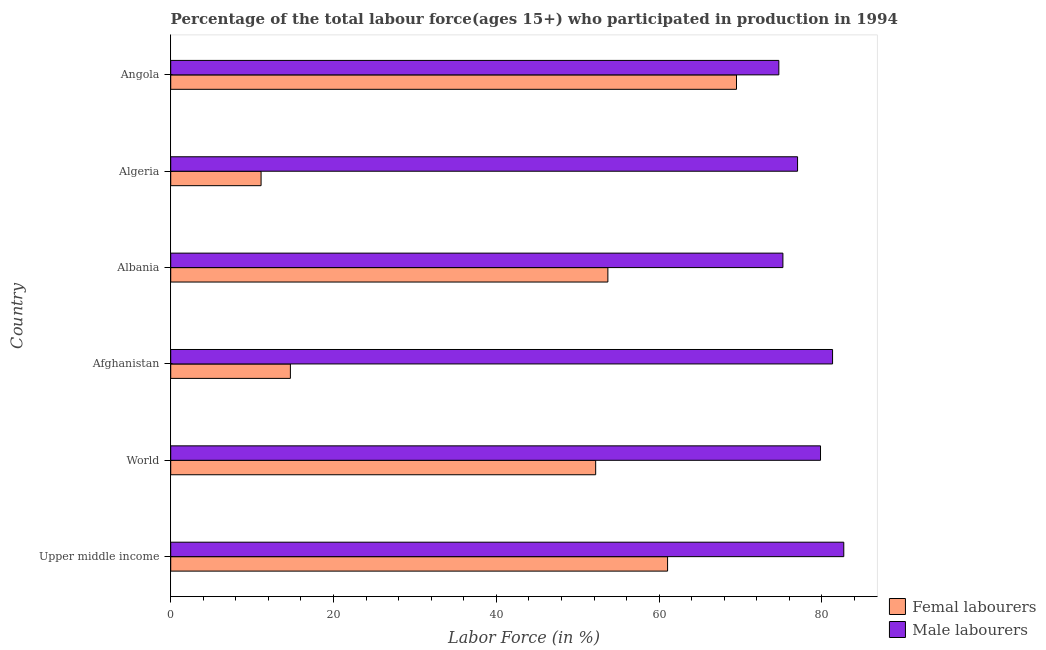How many different coloured bars are there?
Keep it short and to the point. 2. How many groups of bars are there?
Offer a very short reply. 6. How many bars are there on the 3rd tick from the top?
Offer a terse response. 2. What is the label of the 1st group of bars from the top?
Your answer should be very brief. Angola. What is the percentage of male labour force in Algeria?
Provide a short and direct response. 77. Across all countries, what is the maximum percentage of male labour force?
Provide a succinct answer. 82.68. Across all countries, what is the minimum percentage of female labor force?
Offer a terse response. 11.1. In which country was the percentage of female labor force maximum?
Your answer should be very brief. Angola. In which country was the percentage of male labour force minimum?
Offer a terse response. Angola. What is the total percentage of female labor force in the graph?
Provide a succinct answer. 262.23. What is the difference between the percentage of male labour force in Angola and the percentage of female labor force in Albania?
Your answer should be compact. 21. What is the average percentage of female labor force per country?
Your answer should be compact. 43.71. What is the difference between the percentage of female labor force and percentage of male labour force in Algeria?
Provide a succinct answer. -65.9. In how many countries, is the percentage of female labor force greater than 24 %?
Your answer should be compact. 4. What is the ratio of the percentage of male labour force in Angola to that in Upper middle income?
Make the answer very short. 0.9. Is the difference between the percentage of male labour force in Angola and World greater than the difference between the percentage of female labor force in Angola and World?
Ensure brevity in your answer.  No. What is the difference between the highest and the second highest percentage of male labour force?
Your response must be concise. 1.38. What is the difference between the highest and the lowest percentage of female labor force?
Your response must be concise. 58.4. Is the sum of the percentage of male labour force in Algeria and Angola greater than the maximum percentage of female labor force across all countries?
Your answer should be very brief. Yes. What does the 1st bar from the top in Angola represents?
Make the answer very short. Male labourers. What does the 1st bar from the bottom in Algeria represents?
Offer a terse response. Femal labourers. Does the graph contain grids?
Ensure brevity in your answer.  No. What is the title of the graph?
Give a very brief answer. Percentage of the total labour force(ages 15+) who participated in production in 1994. What is the label or title of the X-axis?
Keep it short and to the point. Labor Force (in %). What is the Labor Force (in %) of Femal labourers in Upper middle income?
Provide a succinct answer. 61.03. What is the Labor Force (in %) in Male labourers in Upper middle income?
Ensure brevity in your answer.  82.68. What is the Labor Force (in %) of Femal labourers in World?
Ensure brevity in your answer.  52.2. What is the Labor Force (in %) of Male labourers in World?
Provide a short and direct response. 79.82. What is the Labor Force (in %) in Femal labourers in Afghanistan?
Your answer should be compact. 14.7. What is the Labor Force (in %) in Male labourers in Afghanistan?
Your response must be concise. 81.3. What is the Labor Force (in %) in Femal labourers in Albania?
Offer a terse response. 53.7. What is the Labor Force (in %) in Male labourers in Albania?
Provide a short and direct response. 75.2. What is the Labor Force (in %) of Femal labourers in Algeria?
Your answer should be compact. 11.1. What is the Labor Force (in %) in Femal labourers in Angola?
Offer a very short reply. 69.5. What is the Labor Force (in %) in Male labourers in Angola?
Offer a very short reply. 74.7. Across all countries, what is the maximum Labor Force (in %) in Femal labourers?
Ensure brevity in your answer.  69.5. Across all countries, what is the maximum Labor Force (in %) in Male labourers?
Make the answer very short. 82.68. Across all countries, what is the minimum Labor Force (in %) in Femal labourers?
Ensure brevity in your answer.  11.1. Across all countries, what is the minimum Labor Force (in %) in Male labourers?
Offer a very short reply. 74.7. What is the total Labor Force (in %) in Femal labourers in the graph?
Provide a succinct answer. 262.23. What is the total Labor Force (in %) of Male labourers in the graph?
Give a very brief answer. 470.7. What is the difference between the Labor Force (in %) in Femal labourers in Upper middle income and that in World?
Your response must be concise. 8.83. What is the difference between the Labor Force (in %) of Male labourers in Upper middle income and that in World?
Make the answer very short. 2.86. What is the difference between the Labor Force (in %) of Femal labourers in Upper middle income and that in Afghanistan?
Provide a succinct answer. 46.33. What is the difference between the Labor Force (in %) in Male labourers in Upper middle income and that in Afghanistan?
Provide a succinct answer. 1.38. What is the difference between the Labor Force (in %) of Femal labourers in Upper middle income and that in Albania?
Your response must be concise. 7.33. What is the difference between the Labor Force (in %) of Male labourers in Upper middle income and that in Albania?
Ensure brevity in your answer.  7.48. What is the difference between the Labor Force (in %) of Femal labourers in Upper middle income and that in Algeria?
Ensure brevity in your answer.  49.93. What is the difference between the Labor Force (in %) in Male labourers in Upper middle income and that in Algeria?
Provide a short and direct response. 5.68. What is the difference between the Labor Force (in %) of Femal labourers in Upper middle income and that in Angola?
Offer a terse response. -8.47. What is the difference between the Labor Force (in %) in Male labourers in Upper middle income and that in Angola?
Ensure brevity in your answer.  7.98. What is the difference between the Labor Force (in %) of Femal labourers in World and that in Afghanistan?
Give a very brief answer. 37.5. What is the difference between the Labor Force (in %) of Male labourers in World and that in Afghanistan?
Your response must be concise. -1.48. What is the difference between the Labor Force (in %) in Femal labourers in World and that in Albania?
Provide a succinct answer. -1.5. What is the difference between the Labor Force (in %) of Male labourers in World and that in Albania?
Provide a succinct answer. 4.62. What is the difference between the Labor Force (in %) of Femal labourers in World and that in Algeria?
Your answer should be compact. 41.1. What is the difference between the Labor Force (in %) in Male labourers in World and that in Algeria?
Keep it short and to the point. 2.82. What is the difference between the Labor Force (in %) in Femal labourers in World and that in Angola?
Provide a succinct answer. -17.3. What is the difference between the Labor Force (in %) in Male labourers in World and that in Angola?
Your answer should be compact. 5.12. What is the difference between the Labor Force (in %) of Femal labourers in Afghanistan and that in Albania?
Provide a short and direct response. -39. What is the difference between the Labor Force (in %) of Male labourers in Afghanistan and that in Albania?
Ensure brevity in your answer.  6.1. What is the difference between the Labor Force (in %) in Femal labourers in Afghanistan and that in Algeria?
Your answer should be very brief. 3.6. What is the difference between the Labor Force (in %) of Femal labourers in Afghanistan and that in Angola?
Your answer should be very brief. -54.8. What is the difference between the Labor Force (in %) in Femal labourers in Albania and that in Algeria?
Your answer should be compact. 42.6. What is the difference between the Labor Force (in %) in Male labourers in Albania and that in Algeria?
Provide a succinct answer. -1.8. What is the difference between the Labor Force (in %) in Femal labourers in Albania and that in Angola?
Offer a very short reply. -15.8. What is the difference between the Labor Force (in %) in Male labourers in Albania and that in Angola?
Your answer should be compact. 0.5. What is the difference between the Labor Force (in %) of Femal labourers in Algeria and that in Angola?
Your answer should be very brief. -58.4. What is the difference between the Labor Force (in %) of Femal labourers in Upper middle income and the Labor Force (in %) of Male labourers in World?
Give a very brief answer. -18.79. What is the difference between the Labor Force (in %) in Femal labourers in Upper middle income and the Labor Force (in %) in Male labourers in Afghanistan?
Your answer should be compact. -20.27. What is the difference between the Labor Force (in %) of Femal labourers in Upper middle income and the Labor Force (in %) of Male labourers in Albania?
Make the answer very short. -14.17. What is the difference between the Labor Force (in %) in Femal labourers in Upper middle income and the Labor Force (in %) in Male labourers in Algeria?
Give a very brief answer. -15.97. What is the difference between the Labor Force (in %) of Femal labourers in Upper middle income and the Labor Force (in %) of Male labourers in Angola?
Keep it short and to the point. -13.67. What is the difference between the Labor Force (in %) of Femal labourers in World and the Labor Force (in %) of Male labourers in Afghanistan?
Your answer should be very brief. -29.1. What is the difference between the Labor Force (in %) of Femal labourers in World and the Labor Force (in %) of Male labourers in Albania?
Offer a very short reply. -23. What is the difference between the Labor Force (in %) of Femal labourers in World and the Labor Force (in %) of Male labourers in Algeria?
Your answer should be very brief. -24.8. What is the difference between the Labor Force (in %) of Femal labourers in World and the Labor Force (in %) of Male labourers in Angola?
Keep it short and to the point. -22.5. What is the difference between the Labor Force (in %) of Femal labourers in Afghanistan and the Labor Force (in %) of Male labourers in Albania?
Provide a succinct answer. -60.5. What is the difference between the Labor Force (in %) in Femal labourers in Afghanistan and the Labor Force (in %) in Male labourers in Algeria?
Provide a succinct answer. -62.3. What is the difference between the Labor Force (in %) in Femal labourers in Afghanistan and the Labor Force (in %) in Male labourers in Angola?
Your answer should be very brief. -60. What is the difference between the Labor Force (in %) of Femal labourers in Albania and the Labor Force (in %) of Male labourers in Algeria?
Provide a succinct answer. -23.3. What is the difference between the Labor Force (in %) of Femal labourers in Algeria and the Labor Force (in %) of Male labourers in Angola?
Provide a short and direct response. -63.6. What is the average Labor Force (in %) of Femal labourers per country?
Your response must be concise. 43.71. What is the average Labor Force (in %) of Male labourers per country?
Your response must be concise. 78.45. What is the difference between the Labor Force (in %) of Femal labourers and Labor Force (in %) of Male labourers in Upper middle income?
Provide a succinct answer. -21.64. What is the difference between the Labor Force (in %) in Femal labourers and Labor Force (in %) in Male labourers in World?
Offer a terse response. -27.62. What is the difference between the Labor Force (in %) of Femal labourers and Labor Force (in %) of Male labourers in Afghanistan?
Offer a terse response. -66.6. What is the difference between the Labor Force (in %) in Femal labourers and Labor Force (in %) in Male labourers in Albania?
Your response must be concise. -21.5. What is the difference between the Labor Force (in %) of Femal labourers and Labor Force (in %) of Male labourers in Algeria?
Your answer should be compact. -65.9. What is the difference between the Labor Force (in %) in Femal labourers and Labor Force (in %) in Male labourers in Angola?
Your response must be concise. -5.2. What is the ratio of the Labor Force (in %) of Femal labourers in Upper middle income to that in World?
Offer a terse response. 1.17. What is the ratio of the Labor Force (in %) in Male labourers in Upper middle income to that in World?
Give a very brief answer. 1.04. What is the ratio of the Labor Force (in %) in Femal labourers in Upper middle income to that in Afghanistan?
Keep it short and to the point. 4.15. What is the ratio of the Labor Force (in %) of Male labourers in Upper middle income to that in Afghanistan?
Offer a terse response. 1.02. What is the ratio of the Labor Force (in %) in Femal labourers in Upper middle income to that in Albania?
Your answer should be compact. 1.14. What is the ratio of the Labor Force (in %) of Male labourers in Upper middle income to that in Albania?
Ensure brevity in your answer.  1.1. What is the ratio of the Labor Force (in %) in Femal labourers in Upper middle income to that in Algeria?
Keep it short and to the point. 5.5. What is the ratio of the Labor Force (in %) of Male labourers in Upper middle income to that in Algeria?
Your response must be concise. 1.07. What is the ratio of the Labor Force (in %) in Femal labourers in Upper middle income to that in Angola?
Ensure brevity in your answer.  0.88. What is the ratio of the Labor Force (in %) of Male labourers in Upper middle income to that in Angola?
Offer a very short reply. 1.11. What is the ratio of the Labor Force (in %) in Femal labourers in World to that in Afghanistan?
Provide a succinct answer. 3.55. What is the ratio of the Labor Force (in %) of Male labourers in World to that in Afghanistan?
Your response must be concise. 0.98. What is the ratio of the Labor Force (in %) in Femal labourers in World to that in Albania?
Ensure brevity in your answer.  0.97. What is the ratio of the Labor Force (in %) of Male labourers in World to that in Albania?
Make the answer very short. 1.06. What is the ratio of the Labor Force (in %) in Femal labourers in World to that in Algeria?
Make the answer very short. 4.7. What is the ratio of the Labor Force (in %) of Male labourers in World to that in Algeria?
Keep it short and to the point. 1.04. What is the ratio of the Labor Force (in %) of Femal labourers in World to that in Angola?
Provide a short and direct response. 0.75. What is the ratio of the Labor Force (in %) in Male labourers in World to that in Angola?
Offer a terse response. 1.07. What is the ratio of the Labor Force (in %) of Femal labourers in Afghanistan to that in Albania?
Give a very brief answer. 0.27. What is the ratio of the Labor Force (in %) of Male labourers in Afghanistan to that in Albania?
Your response must be concise. 1.08. What is the ratio of the Labor Force (in %) of Femal labourers in Afghanistan to that in Algeria?
Your response must be concise. 1.32. What is the ratio of the Labor Force (in %) in Male labourers in Afghanistan to that in Algeria?
Give a very brief answer. 1.06. What is the ratio of the Labor Force (in %) in Femal labourers in Afghanistan to that in Angola?
Make the answer very short. 0.21. What is the ratio of the Labor Force (in %) in Male labourers in Afghanistan to that in Angola?
Offer a terse response. 1.09. What is the ratio of the Labor Force (in %) in Femal labourers in Albania to that in Algeria?
Give a very brief answer. 4.84. What is the ratio of the Labor Force (in %) of Male labourers in Albania to that in Algeria?
Your response must be concise. 0.98. What is the ratio of the Labor Force (in %) in Femal labourers in Albania to that in Angola?
Offer a terse response. 0.77. What is the ratio of the Labor Force (in %) of Male labourers in Albania to that in Angola?
Your answer should be compact. 1.01. What is the ratio of the Labor Force (in %) of Femal labourers in Algeria to that in Angola?
Your answer should be compact. 0.16. What is the ratio of the Labor Force (in %) in Male labourers in Algeria to that in Angola?
Keep it short and to the point. 1.03. What is the difference between the highest and the second highest Labor Force (in %) of Femal labourers?
Keep it short and to the point. 8.47. What is the difference between the highest and the second highest Labor Force (in %) in Male labourers?
Provide a succinct answer. 1.38. What is the difference between the highest and the lowest Labor Force (in %) in Femal labourers?
Give a very brief answer. 58.4. What is the difference between the highest and the lowest Labor Force (in %) in Male labourers?
Offer a terse response. 7.98. 